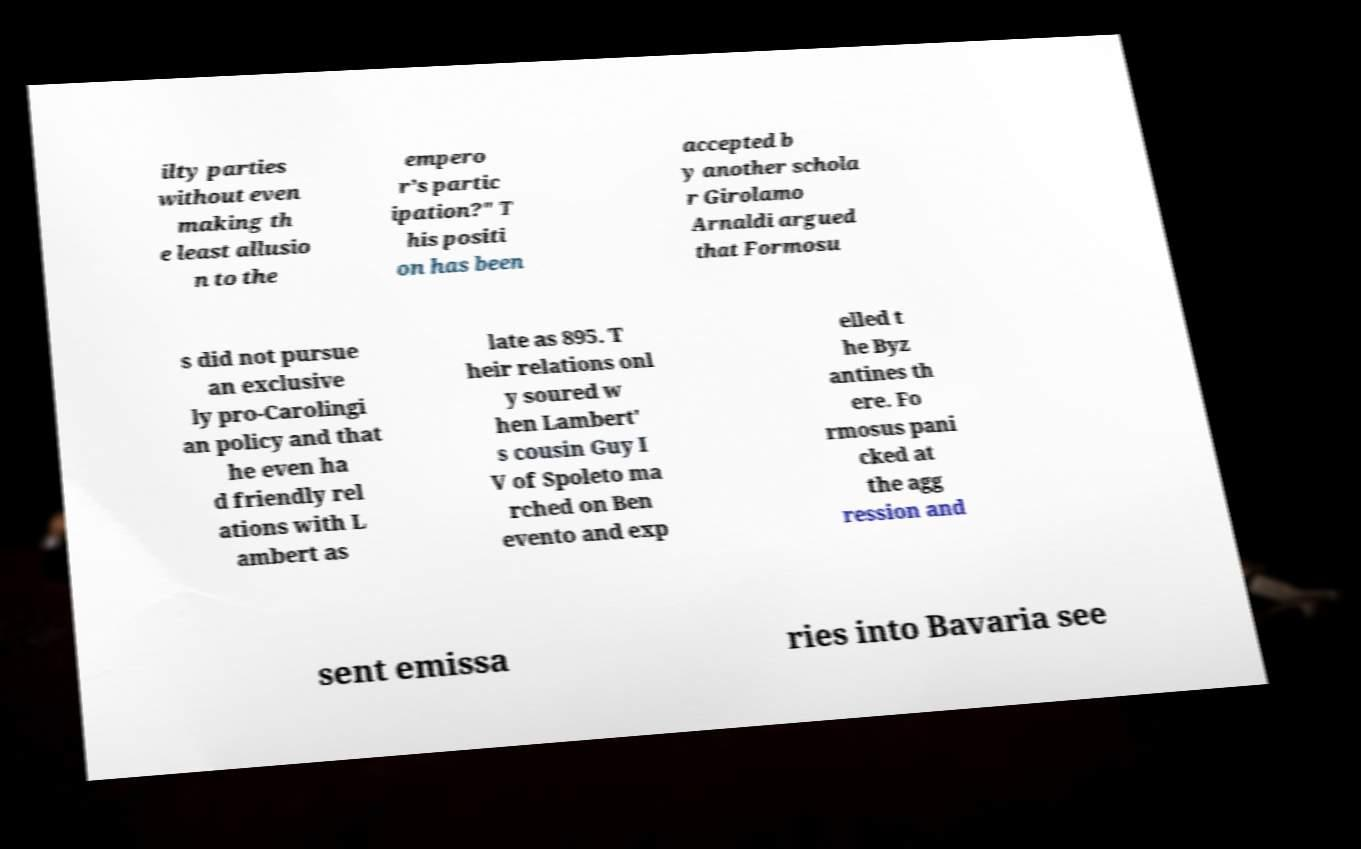I need the written content from this picture converted into text. Can you do that? ilty parties without even making th e least allusio n to the empero r’s partic ipation?" T his positi on has been accepted b y another schola r Girolamo Arnaldi argued that Formosu s did not pursue an exclusive ly pro-Carolingi an policy and that he even ha d friendly rel ations with L ambert as late as 895. T heir relations onl y soured w hen Lambert' s cousin Guy I V of Spoleto ma rched on Ben evento and exp elled t he Byz antines th ere. Fo rmosus pani cked at the agg ression and sent emissa ries into Bavaria see 